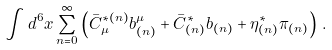Convert formula to latex. <formula><loc_0><loc_0><loc_500><loc_500>\int d ^ { 6 } x \sum _ { n = 0 } ^ { \infty } \left ( \bar { C } _ { \mu } ^ { * ( n ) } b _ { ( n ) } ^ { \mu } + \bar { C } _ { ( n ) } ^ { * } b _ { ( n ) } + \eta _ { ( n ) } ^ { * } \pi _ { ( n ) } \right ) \, .</formula> 